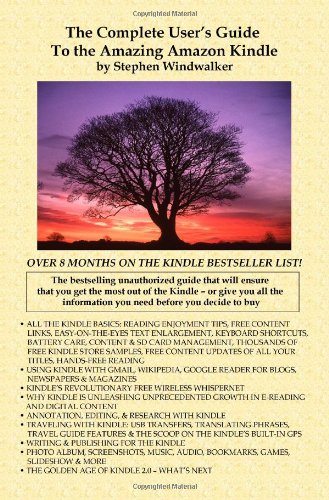Is this a digital technology book? Yes, the book's focus on the Amazon Kindle, a popular e-reader, categorizes it securely within the digital technology genre. 